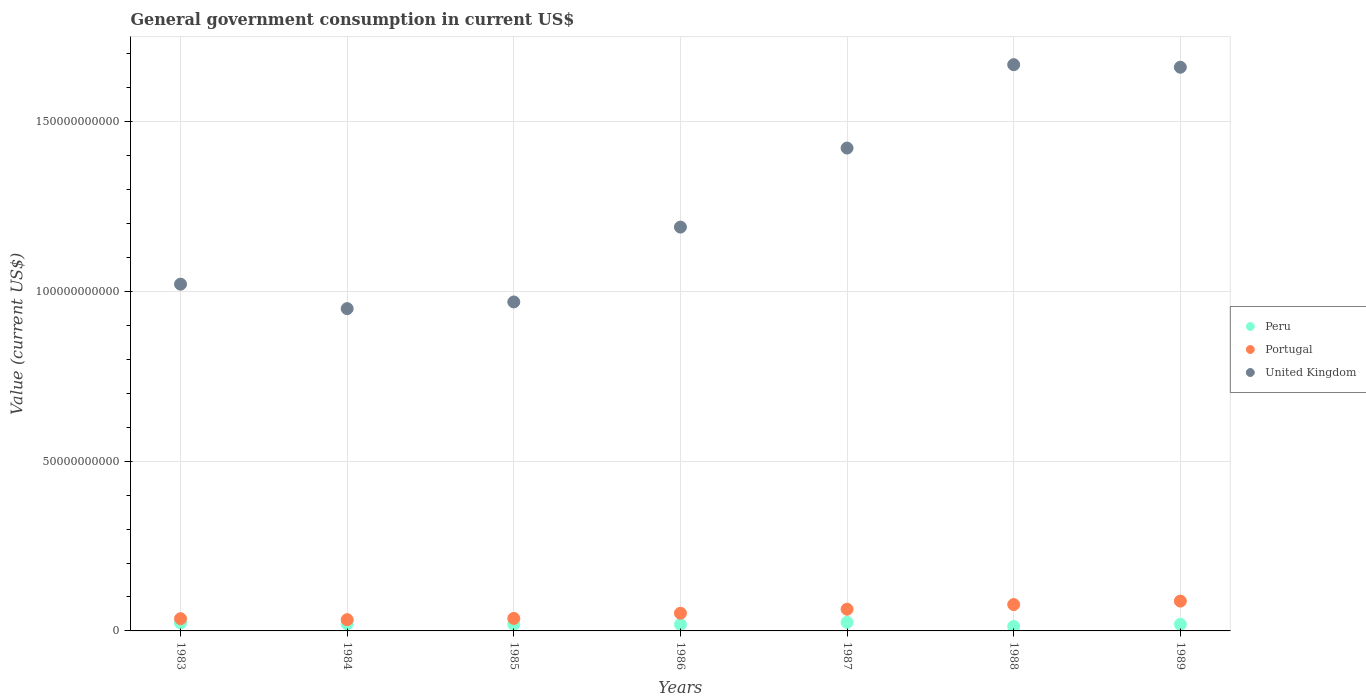How many different coloured dotlines are there?
Your response must be concise. 3. Is the number of dotlines equal to the number of legend labels?
Offer a very short reply. Yes. What is the government conusmption in Peru in 1984?
Offer a terse response. 2.08e+09. Across all years, what is the maximum government conusmption in Portugal?
Offer a terse response. 8.79e+09. Across all years, what is the minimum government conusmption in Portugal?
Offer a very short reply. 3.32e+09. In which year was the government conusmption in United Kingdom maximum?
Provide a short and direct response. 1988. In which year was the government conusmption in Portugal minimum?
Provide a succinct answer. 1984. What is the total government conusmption in Portugal in the graph?
Offer a terse response. 3.88e+1. What is the difference between the government conusmption in Peru in 1983 and that in 1987?
Keep it short and to the point. -1.93e+08. What is the difference between the government conusmption in Peru in 1985 and the government conusmption in Portugal in 1988?
Your response must be concise. -5.83e+09. What is the average government conusmption in Peru per year?
Keep it short and to the point. 2.00e+09. In the year 1986, what is the difference between the government conusmption in United Kingdom and government conusmption in Peru?
Make the answer very short. 1.17e+11. In how many years, is the government conusmption in Peru greater than 40000000000 US$?
Your answer should be compact. 0. What is the ratio of the government conusmption in United Kingdom in 1986 to that in 1987?
Keep it short and to the point. 0.84. Is the government conusmption in Peru in 1986 less than that in 1987?
Keep it short and to the point. Yes. What is the difference between the highest and the second highest government conusmption in Portugal?
Offer a very short reply. 1.02e+09. What is the difference between the highest and the lowest government conusmption in United Kingdom?
Give a very brief answer. 7.19e+1. In how many years, is the government conusmption in Portugal greater than the average government conusmption in Portugal taken over all years?
Provide a succinct answer. 3. Is the government conusmption in Peru strictly greater than the government conusmption in Portugal over the years?
Your answer should be compact. No. Is the government conusmption in Portugal strictly less than the government conusmption in United Kingdom over the years?
Provide a short and direct response. Yes. How many years are there in the graph?
Ensure brevity in your answer.  7. Does the graph contain any zero values?
Ensure brevity in your answer.  No. Where does the legend appear in the graph?
Offer a terse response. Center right. How many legend labels are there?
Offer a terse response. 3. How are the legend labels stacked?
Offer a very short reply. Vertical. What is the title of the graph?
Your answer should be very brief. General government consumption in current US$. Does "Brunei Darussalam" appear as one of the legend labels in the graph?
Offer a terse response. No. What is the label or title of the Y-axis?
Make the answer very short. Value (current US$). What is the Value (current US$) in Peru in 1983?
Your answer should be very brief. 2.33e+09. What is the Value (current US$) in Portugal in 1983?
Provide a short and direct response. 3.61e+09. What is the Value (current US$) of United Kingdom in 1983?
Your response must be concise. 1.02e+11. What is the Value (current US$) of Peru in 1984?
Provide a short and direct response. 2.08e+09. What is the Value (current US$) of Portugal in 1984?
Make the answer very short. 3.32e+09. What is the Value (current US$) of United Kingdom in 1984?
Make the answer very short. 9.49e+1. What is the Value (current US$) in Peru in 1985?
Make the answer very short. 1.94e+09. What is the Value (current US$) in Portugal in 1985?
Give a very brief answer. 3.68e+09. What is the Value (current US$) in United Kingdom in 1985?
Make the answer very short. 9.69e+1. What is the Value (current US$) in Peru in 1986?
Offer a very short reply. 1.90e+09. What is the Value (current US$) in Portugal in 1986?
Provide a succinct answer. 5.21e+09. What is the Value (current US$) of United Kingdom in 1986?
Make the answer very short. 1.19e+11. What is the Value (current US$) of Peru in 1987?
Your answer should be very brief. 2.53e+09. What is the Value (current US$) of Portugal in 1987?
Provide a succinct answer. 6.40e+09. What is the Value (current US$) in United Kingdom in 1987?
Offer a very short reply. 1.42e+11. What is the Value (current US$) in Peru in 1988?
Give a very brief answer. 1.31e+09. What is the Value (current US$) of Portugal in 1988?
Offer a very short reply. 7.77e+09. What is the Value (current US$) of United Kingdom in 1988?
Provide a short and direct response. 1.67e+11. What is the Value (current US$) of Peru in 1989?
Provide a short and direct response. 1.93e+09. What is the Value (current US$) in Portugal in 1989?
Offer a very short reply. 8.79e+09. What is the Value (current US$) in United Kingdom in 1989?
Keep it short and to the point. 1.66e+11. Across all years, what is the maximum Value (current US$) of Peru?
Your response must be concise. 2.53e+09. Across all years, what is the maximum Value (current US$) of Portugal?
Give a very brief answer. 8.79e+09. Across all years, what is the maximum Value (current US$) of United Kingdom?
Provide a short and direct response. 1.67e+11. Across all years, what is the minimum Value (current US$) in Peru?
Keep it short and to the point. 1.31e+09. Across all years, what is the minimum Value (current US$) of Portugal?
Keep it short and to the point. 3.32e+09. Across all years, what is the minimum Value (current US$) in United Kingdom?
Your response must be concise. 9.49e+1. What is the total Value (current US$) in Peru in the graph?
Provide a short and direct response. 1.40e+1. What is the total Value (current US$) in Portugal in the graph?
Give a very brief answer. 3.88e+1. What is the total Value (current US$) in United Kingdom in the graph?
Give a very brief answer. 8.88e+11. What is the difference between the Value (current US$) in Peru in 1983 and that in 1984?
Make the answer very short. 2.57e+08. What is the difference between the Value (current US$) of Portugal in 1983 and that in 1984?
Offer a terse response. 2.92e+08. What is the difference between the Value (current US$) of United Kingdom in 1983 and that in 1984?
Give a very brief answer. 7.21e+09. What is the difference between the Value (current US$) in Peru in 1983 and that in 1985?
Your answer should be very brief. 3.93e+08. What is the difference between the Value (current US$) of Portugal in 1983 and that in 1985?
Your response must be concise. -7.50e+07. What is the difference between the Value (current US$) of United Kingdom in 1983 and that in 1985?
Your response must be concise. 5.25e+09. What is the difference between the Value (current US$) in Peru in 1983 and that in 1986?
Your answer should be very brief. 4.38e+08. What is the difference between the Value (current US$) of Portugal in 1983 and that in 1986?
Offer a very short reply. -1.60e+09. What is the difference between the Value (current US$) of United Kingdom in 1983 and that in 1986?
Give a very brief answer. -1.68e+1. What is the difference between the Value (current US$) of Peru in 1983 and that in 1987?
Your answer should be compact. -1.93e+08. What is the difference between the Value (current US$) in Portugal in 1983 and that in 1987?
Give a very brief answer. -2.79e+09. What is the difference between the Value (current US$) in United Kingdom in 1983 and that in 1987?
Give a very brief answer. -4.01e+1. What is the difference between the Value (current US$) of Peru in 1983 and that in 1988?
Your answer should be very brief. 1.02e+09. What is the difference between the Value (current US$) of Portugal in 1983 and that in 1988?
Keep it short and to the point. -4.16e+09. What is the difference between the Value (current US$) of United Kingdom in 1983 and that in 1988?
Offer a very short reply. -6.46e+1. What is the difference between the Value (current US$) of Peru in 1983 and that in 1989?
Make the answer very short. 4.02e+08. What is the difference between the Value (current US$) of Portugal in 1983 and that in 1989?
Offer a terse response. -5.18e+09. What is the difference between the Value (current US$) of United Kingdom in 1983 and that in 1989?
Offer a terse response. -6.39e+1. What is the difference between the Value (current US$) in Peru in 1984 and that in 1985?
Offer a very short reply. 1.37e+08. What is the difference between the Value (current US$) in Portugal in 1984 and that in 1985?
Your answer should be very brief. -3.67e+08. What is the difference between the Value (current US$) of United Kingdom in 1984 and that in 1985?
Offer a terse response. -1.96e+09. What is the difference between the Value (current US$) in Peru in 1984 and that in 1986?
Offer a terse response. 1.82e+08. What is the difference between the Value (current US$) in Portugal in 1984 and that in 1986?
Your answer should be compact. -1.89e+09. What is the difference between the Value (current US$) in United Kingdom in 1984 and that in 1986?
Provide a succinct answer. -2.40e+1. What is the difference between the Value (current US$) in Peru in 1984 and that in 1987?
Your answer should be compact. -4.50e+08. What is the difference between the Value (current US$) in Portugal in 1984 and that in 1987?
Your answer should be very brief. -3.08e+09. What is the difference between the Value (current US$) of United Kingdom in 1984 and that in 1987?
Offer a very short reply. -4.73e+1. What is the difference between the Value (current US$) in Peru in 1984 and that in 1988?
Keep it short and to the point. 7.63e+08. What is the difference between the Value (current US$) in Portugal in 1984 and that in 1988?
Ensure brevity in your answer.  -4.45e+09. What is the difference between the Value (current US$) in United Kingdom in 1984 and that in 1988?
Offer a terse response. -7.19e+1. What is the difference between the Value (current US$) in Peru in 1984 and that in 1989?
Offer a very short reply. 1.45e+08. What is the difference between the Value (current US$) of Portugal in 1984 and that in 1989?
Your answer should be compact. -5.47e+09. What is the difference between the Value (current US$) in United Kingdom in 1984 and that in 1989?
Give a very brief answer. -7.11e+1. What is the difference between the Value (current US$) of Peru in 1985 and that in 1986?
Your answer should be very brief. 4.50e+07. What is the difference between the Value (current US$) in Portugal in 1985 and that in 1986?
Make the answer very short. -1.52e+09. What is the difference between the Value (current US$) of United Kingdom in 1985 and that in 1986?
Your answer should be very brief. -2.21e+1. What is the difference between the Value (current US$) in Peru in 1985 and that in 1987?
Your response must be concise. -5.87e+08. What is the difference between the Value (current US$) in Portugal in 1985 and that in 1987?
Your response must be concise. -2.71e+09. What is the difference between the Value (current US$) in United Kingdom in 1985 and that in 1987?
Make the answer very short. -4.53e+1. What is the difference between the Value (current US$) in Peru in 1985 and that in 1988?
Your response must be concise. 6.26e+08. What is the difference between the Value (current US$) of Portugal in 1985 and that in 1988?
Ensure brevity in your answer.  -4.08e+09. What is the difference between the Value (current US$) in United Kingdom in 1985 and that in 1988?
Your answer should be compact. -6.99e+1. What is the difference between the Value (current US$) in Peru in 1985 and that in 1989?
Provide a succinct answer. 8.56e+06. What is the difference between the Value (current US$) of Portugal in 1985 and that in 1989?
Offer a very short reply. -5.10e+09. What is the difference between the Value (current US$) of United Kingdom in 1985 and that in 1989?
Provide a short and direct response. -6.91e+1. What is the difference between the Value (current US$) of Peru in 1986 and that in 1987?
Provide a succinct answer. -6.32e+08. What is the difference between the Value (current US$) in Portugal in 1986 and that in 1987?
Give a very brief answer. -1.19e+09. What is the difference between the Value (current US$) of United Kingdom in 1986 and that in 1987?
Ensure brevity in your answer.  -2.33e+1. What is the difference between the Value (current US$) in Peru in 1986 and that in 1988?
Your response must be concise. 5.81e+08. What is the difference between the Value (current US$) of Portugal in 1986 and that in 1988?
Offer a very short reply. -2.56e+09. What is the difference between the Value (current US$) of United Kingdom in 1986 and that in 1988?
Keep it short and to the point. -4.78e+1. What is the difference between the Value (current US$) in Peru in 1986 and that in 1989?
Your response must be concise. -3.64e+07. What is the difference between the Value (current US$) of Portugal in 1986 and that in 1989?
Offer a terse response. -3.58e+09. What is the difference between the Value (current US$) in United Kingdom in 1986 and that in 1989?
Your answer should be compact. -4.71e+1. What is the difference between the Value (current US$) in Peru in 1987 and that in 1988?
Ensure brevity in your answer.  1.21e+09. What is the difference between the Value (current US$) of Portugal in 1987 and that in 1988?
Provide a short and direct response. -1.37e+09. What is the difference between the Value (current US$) of United Kingdom in 1987 and that in 1988?
Your answer should be compact. -2.46e+1. What is the difference between the Value (current US$) in Peru in 1987 and that in 1989?
Make the answer very short. 5.95e+08. What is the difference between the Value (current US$) of Portugal in 1987 and that in 1989?
Keep it short and to the point. -2.39e+09. What is the difference between the Value (current US$) of United Kingdom in 1987 and that in 1989?
Ensure brevity in your answer.  -2.38e+1. What is the difference between the Value (current US$) of Peru in 1988 and that in 1989?
Your response must be concise. -6.18e+08. What is the difference between the Value (current US$) in Portugal in 1988 and that in 1989?
Ensure brevity in your answer.  -1.02e+09. What is the difference between the Value (current US$) in United Kingdom in 1988 and that in 1989?
Offer a very short reply. 7.54e+08. What is the difference between the Value (current US$) in Peru in 1983 and the Value (current US$) in Portugal in 1984?
Provide a short and direct response. -9.84e+08. What is the difference between the Value (current US$) of Peru in 1983 and the Value (current US$) of United Kingdom in 1984?
Offer a terse response. -9.26e+1. What is the difference between the Value (current US$) of Portugal in 1983 and the Value (current US$) of United Kingdom in 1984?
Keep it short and to the point. -9.13e+1. What is the difference between the Value (current US$) in Peru in 1983 and the Value (current US$) in Portugal in 1985?
Give a very brief answer. -1.35e+09. What is the difference between the Value (current US$) of Peru in 1983 and the Value (current US$) of United Kingdom in 1985?
Make the answer very short. -9.46e+1. What is the difference between the Value (current US$) in Portugal in 1983 and the Value (current US$) in United Kingdom in 1985?
Ensure brevity in your answer.  -9.33e+1. What is the difference between the Value (current US$) in Peru in 1983 and the Value (current US$) in Portugal in 1986?
Provide a succinct answer. -2.88e+09. What is the difference between the Value (current US$) of Peru in 1983 and the Value (current US$) of United Kingdom in 1986?
Give a very brief answer. -1.17e+11. What is the difference between the Value (current US$) in Portugal in 1983 and the Value (current US$) in United Kingdom in 1986?
Give a very brief answer. -1.15e+11. What is the difference between the Value (current US$) in Peru in 1983 and the Value (current US$) in Portugal in 1987?
Provide a short and direct response. -4.06e+09. What is the difference between the Value (current US$) of Peru in 1983 and the Value (current US$) of United Kingdom in 1987?
Make the answer very short. -1.40e+11. What is the difference between the Value (current US$) of Portugal in 1983 and the Value (current US$) of United Kingdom in 1987?
Provide a short and direct response. -1.39e+11. What is the difference between the Value (current US$) in Peru in 1983 and the Value (current US$) in Portugal in 1988?
Make the answer very short. -5.43e+09. What is the difference between the Value (current US$) of Peru in 1983 and the Value (current US$) of United Kingdom in 1988?
Your answer should be very brief. -1.64e+11. What is the difference between the Value (current US$) in Portugal in 1983 and the Value (current US$) in United Kingdom in 1988?
Give a very brief answer. -1.63e+11. What is the difference between the Value (current US$) of Peru in 1983 and the Value (current US$) of Portugal in 1989?
Give a very brief answer. -6.45e+09. What is the difference between the Value (current US$) of Peru in 1983 and the Value (current US$) of United Kingdom in 1989?
Ensure brevity in your answer.  -1.64e+11. What is the difference between the Value (current US$) of Portugal in 1983 and the Value (current US$) of United Kingdom in 1989?
Offer a terse response. -1.62e+11. What is the difference between the Value (current US$) in Peru in 1984 and the Value (current US$) in Portugal in 1985?
Ensure brevity in your answer.  -1.61e+09. What is the difference between the Value (current US$) in Peru in 1984 and the Value (current US$) in United Kingdom in 1985?
Give a very brief answer. -9.48e+1. What is the difference between the Value (current US$) in Portugal in 1984 and the Value (current US$) in United Kingdom in 1985?
Your response must be concise. -9.36e+1. What is the difference between the Value (current US$) in Peru in 1984 and the Value (current US$) in Portugal in 1986?
Ensure brevity in your answer.  -3.13e+09. What is the difference between the Value (current US$) in Peru in 1984 and the Value (current US$) in United Kingdom in 1986?
Your answer should be compact. -1.17e+11. What is the difference between the Value (current US$) in Portugal in 1984 and the Value (current US$) in United Kingdom in 1986?
Provide a succinct answer. -1.16e+11. What is the difference between the Value (current US$) in Peru in 1984 and the Value (current US$) in Portugal in 1987?
Keep it short and to the point. -4.32e+09. What is the difference between the Value (current US$) of Peru in 1984 and the Value (current US$) of United Kingdom in 1987?
Give a very brief answer. -1.40e+11. What is the difference between the Value (current US$) in Portugal in 1984 and the Value (current US$) in United Kingdom in 1987?
Make the answer very short. -1.39e+11. What is the difference between the Value (current US$) of Peru in 1984 and the Value (current US$) of Portugal in 1988?
Ensure brevity in your answer.  -5.69e+09. What is the difference between the Value (current US$) in Peru in 1984 and the Value (current US$) in United Kingdom in 1988?
Provide a short and direct response. -1.65e+11. What is the difference between the Value (current US$) in Portugal in 1984 and the Value (current US$) in United Kingdom in 1988?
Offer a very short reply. -1.63e+11. What is the difference between the Value (current US$) in Peru in 1984 and the Value (current US$) in Portugal in 1989?
Your answer should be very brief. -6.71e+09. What is the difference between the Value (current US$) in Peru in 1984 and the Value (current US$) in United Kingdom in 1989?
Provide a short and direct response. -1.64e+11. What is the difference between the Value (current US$) of Portugal in 1984 and the Value (current US$) of United Kingdom in 1989?
Give a very brief answer. -1.63e+11. What is the difference between the Value (current US$) of Peru in 1985 and the Value (current US$) of Portugal in 1986?
Your answer should be very brief. -3.27e+09. What is the difference between the Value (current US$) in Peru in 1985 and the Value (current US$) in United Kingdom in 1986?
Ensure brevity in your answer.  -1.17e+11. What is the difference between the Value (current US$) in Portugal in 1985 and the Value (current US$) in United Kingdom in 1986?
Offer a terse response. -1.15e+11. What is the difference between the Value (current US$) of Peru in 1985 and the Value (current US$) of Portugal in 1987?
Give a very brief answer. -4.46e+09. What is the difference between the Value (current US$) in Peru in 1985 and the Value (current US$) in United Kingdom in 1987?
Provide a short and direct response. -1.40e+11. What is the difference between the Value (current US$) of Portugal in 1985 and the Value (current US$) of United Kingdom in 1987?
Make the answer very short. -1.39e+11. What is the difference between the Value (current US$) in Peru in 1985 and the Value (current US$) in Portugal in 1988?
Your answer should be compact. -5.83e+09. What is the difference between the Value (current US$) in Peru in 1985 and the Value (current US$) in United Kingdom in 1988?
Your answer should be compact. -1.65e+11. What is the difference between the Value (current US$) of Portugal in 1985 and the Value (current US$) of United Kingdom in 1988?
Provide a short and direct response. -1.63e+11. What is the difference between the Value (current US$) in Peru in 1985 and the Value (current US$) in Portugal in 1989?
Offer a very short reply. -6.85e+09. What is the difference between the Value (current US$) in Peru in 1985 and the Value (current US$) in United Kingdom in 1989?
Offer a very short reply. -1.64e+11. What is the difference between the Value (current US$) of Portugal in 1985 and the Value (current US$) of United Kingdom in 1989?
Your answer should be compact. -1.62e+11. What is the difference between the Value (current US$) of Peru in 1986 and the Value (current US$) of Portugal in 1987?
Make the answer very short. -4.50e+09. What is the difference between the Value (current US$) in Peru in 1986 and the Value (current US$) in United Kingdom in 1987?
Your answer should be compact. -1.40e+11. What is the difference between the Value (current US$) in Portugal in 1986 and the Value (current US$) in United Kingdom in 1987?
Provide a short and direct response. -1.37e+11. What is the difference between the Value (current US$) in Peru in 1986 and the Value (current US$) in Portugal in 1988?
Provide a succinct answer. -5.87e+09. What is the difference between the Value (current US$) of Peru in 1986 and the Value (current US$) of United Kingdom in 1988?
Your answer should be compact. -1.65e+11. What is the difference between the Value (current US$) of Portugal in 1986 and the Value (current US$) of United Kingdom in 1988?
Provide a short and direct response. -1.62e+11. What is the difference between the Value (current US$) of Peru in 1986 and the Value (current US$) of Portugal in 1989?
Your answer should be very brief. -6.89e+09. What is the difference between the Value (current US$) in Peru in 1986 and the Value (current US$) in United Kingdom in 1989?
Give a very brief answer. -1.64e+11. What is the difference between the Value (current US$) of Portugal in 1986 and the Value (current US$) of United Kingdom in 1989?
Keep it short and to the point. -1.61e+11. What is the difference between the Value (current US$) of Peru in 1987 and the Value (current US$) of Portugal in 1988?
Your response must be concise. -5.24e+09. What is the difference between the Value (current US$) in Peru in 1987 and the Value (current US$) in United Kingdom in 1988?
Your answer should be very brief. -1.64e+11. What is the difference between the Value (current US$) in Portugal in 1987 and the Value (current US$) in United Kingdom in 1988?
Provide a short and direct response. -1.60e+11. What is the difference between the Value (current US$) in Peru in 1987 and the Value (current US$) in Portugal in 1989?
Your answer should be compact. -6.26e+09. What is the difference between the Value (current US$) of Peru in 1987 and the Value (current US$) of United Kingdom in 1989?
Make the answer very short. -1.64e+11. What is the difference between the Value (current US$) in Portugal in 1987 and the Value (current US$) in United Kingdom in 1989?
Give a very brief answer. -1.60e+11. What is the difference between the Value (current US$) of Peru in 1988 and the Value (current US$) of Portugal in 1989?
Ensure brevity in your answer.  -7.47e+09. What is the difference between the Value (current US$) in Peru in 1988 and the Value (current US$) in United Kingdom in 1989?
Offer a very short reply. -1.65e+11. What is the difference between the Value (current US$) in Portugal in 1988 and the Value (current US$) in United Kingdom in 1989?
Offer a terse response. -1.58e+11. What is the average Value (current US$) of Peru per year?
Your response must be concise. 2.00e+09. What is the average Value (current US$) of Portugal per year?
Offer a terse response. 5.54e+09. What is the average Value (current US$) of United Kingdom per year?
Your response must be concise. 1.27e+11. In the year 1983, what is the difference between the Value (current US$) in Peru and Value (current US$) in Portugal?
Your response must be concise. -1.28e+09. In the year 1983, what is the difference between the Value (current US$) of Peru and Value (current US$) of United Kingdom?
Ensure brevity in your answer.  -9.98e+1. In the year 1983, what is the difference between the Value (current US$) of Portugal and Value (current US$) of United Kingdom?
Offer a very short reply. -9.85e+1. In the year 1984, what is the difference between the Value (current US$) in Peru and Value (current US$) in Portugal?
Your response must be concise. -1.24e+09. In the year 1984, what is the difference between the Value (current US$) of Peru and Value (current US$) of United Kingdom?
Keep it short and to the point. -9.29e+1. In the year 1984, what is the difference between the Value (current US$) in Portugal and Value (current US$) in United Kingdom?
Provide a succinct answer. -9.16e+1. In the year 1985, what is the difference between the Value (current US$) of Peru and Value (current US$) of Portugal?
Provide a short and direct response. -1.74e+09. In the year 1985, what is the difference between the Value (current US$) in Peru and Value (current US$) in United Kingdom?
Your answer should be compact. -9.50e+1. In the year 1985, what is the difference between the Value (current US$) in Portugal and Value (current US$) in United Kingdom?
Your response must be concise. -9.32e+1. In the year 1986, what is the difference between the Value (current US$) in Peru and Value (current US$) in Portugal?
Ensure brevity in your answer.  -3.31e+09. In the year 1986, what is the difference between the Value (current US$) in Peru and Value (current US$) in United Kingdom?
Ensure brevity in your answer.  -1.17e+11. In the year 1986, what is the difference between the Value (current US$) of Portugal and Value (current US$) of United Kingdom?
Provide a succinct answer. -1.14e+11. In the year 1987, what is the difference between the Value (current US$) of Peru and Value (current US$) of Portugal?
Your response must be concise. -3.87e+09. In the year 1987, what is the difference between the Value (current US$) in Peru and Value (current US$) in United Kingdom?
Keep it short and to the point. -1.40e+11. In the year 1987, what is the difference between the Value (current US$) of Portugal and Value (current US$) of United Kingdom?
Offer a very short reply. -1.36e+11. In the year 1988, what is the difference between the Value (current US$) in Peru and Value (current US$) in Portugal?
Make the answer very short. -6.45e+09. In the year 1988, what is the difference between the Value (current US$) in Peru and Value (current US$) in United Kingdom?
Provide a short and direct response. -1.65e+11. In the year 1988, what is the difference between the Value (current US$) in Portugal and Value (current US$) in United Kingdom?
Give a very brief answer. -1.59e+11. In the year 1989, what is the difference between the Value (current US$) in Peru and Value (current US$) in Portugal?
Give a very brief answer. -6.85e+09. In the year 1989, what is the difference between the Value (current US$) of Peru and Value (current US$) of United Kingdom?
Ensure brevity in your answer.  -1.64e+11. In the year 1989, what is the difference between the Value (current US$) of Portugal and Value (current US$) of United Kingdom?
Keep it short and to the point. -1.57e+11. What is the ratio of the Value (current US$) of Peru in 1983 to that in 1984?
Make the answer very short. 1.12. What is the ratio of the Value (current US$) of Portugal in 1983 to that in 1984?
Your answer should be very brief. 1.09. What is the ratio of the Value (current US$) in United Kingdom in 1983 to that in 1984?
Keep it short and to the point. 1.08. What is the ratio of the Value (current US$) of Peru in 1983 to that in 1985?
Ensure brevity in your answer.  1.2. What is the ratio of the Value (current US$) of Portugal in 1983 to that in 1985?
Give a very brief answer. 0.98. What is the ratio of the Value (current US$) of United Kingdom in 1983 to that in 1985?
Provide a short and direct response. 1.05. What is the ratio of the Value (current US$) of Peru in 1983 to that in 1986?
Ensure brevity in your answer.  1.23. What is the ratio of the Value (current US$) of Portugal in 1983 to that in 1986?
Your response must be concise. 0.69. What is the ratio of the Value (current US$) of United Kingdom in 1983 to that in 1986?
Offer a terse response. 0.86. What is the ratio of the Value (current US$) of Peru in 1983 to that in 1987?
Your response must be concise. 0.92. What is the ratio of the Value (current US$) of Portugal in 1983 to that in 1987?
Ensure brevity in your answer.  0.56. What is the ratio of the Value (current US$) of United Kingdom in 1983 to that in 1987?
Ensure brevity in your answer.  0.72. What is the ratio of the Value (current US$) of Peru in 1983 to that in 1988?
Give a very brief answer. 1.78. What is the ratio of the Value (current US$) in Portugal in 1983 to that in 1988?
Your response must be concise. 0.46. What is the ratio of the Value (current US$) of United Kingdom in 1983 to that in 1988?
Provide a succinct answer. 0.61. What is the ratio of the Value (current US$) of Peru in 1983 to that in 1989?
Your response must be concise. 1.21. What is the ratio of the Value (current US$) in Portugal in 1983 to that in 1989?
Provide a succinct answer. 0.41. What is the ratio of the Value (current US$) of United Kingdom in 1983 to that in 1989?
Offer a terse response. 0.62. What is the ratio of the Value (current US$) of Peru in 1984 to that in 1985?
Your response must be concise. 1.07. What is the ratio of the Value (current US$) of Portugal in 1984 to that in 1985?
Make the answer very short. 0.9. What is the ratio of the Value (current US$) in United Kingdom in 1984 to that in 1985?
Provide a succinct answer. 0.98. What is the ratio of the Value (current US$) in Peru in 1984 to that in 1986?
Your answer should be very brief. 1.1. What is the ratio of the Value (current US$) of Portugal in 1984 to that in 1986?
Your response must be concise. 0.64. What is the ratio of the Value (current US$) of United Kingdom in 1984 to that in 1986?
Your response must be concise. 0.8. What is the ratio of the Value (current US$) of Peru in 1984 to that in 1987?
Make the answer very short. 0.82. What is the ratio of the Value (current US$) in Portugal in 1984 to that in 1987?
Offer a very short reply. 0.52. What is the ratio of the Value (current US$) in United Kingdom in 1984 to that in 1987?
Your answer should be compact. 0.67. What is the ratio of the Value (current US$) in Peru in 1984 to that in 1988?
Give a very brief answer. 1.58. What is the ratio of the Value (current US$) in Portugal in 1984 to that in 1988?
Your answer should be compact. 0.43. What is the ratio of the Value (current US$) of United Kingdom in 1984 to that in 1988?
Give a very brief answer. 0.57. What is the ratio of the Value (current US$) of Peru in 1984 to that in 1989?
Keep it short and to the point. 1.08. What is the ratio of the Value (current US$) of Portugal in 1984 to that in 1989?
Your response must be concise. 0.38. What is the ratio of the Value (current US$) in United Kingdom in 1984 to that in 1989?
Offer a very short reply. 0.57. What is the ratio of the Value (current US$) in Peru in 1985 to that in 1986?
Keep it short and to the point. 1.02. What is the ratio of the Value (current US$) of Portugal in 1985 to that in 1986?
Your answer should be compact. 0.71. What is the ratio of the Value (current US$) of United Kingdom in 1985 to that in 1986?
Give a very brief answer. 0.81. What is the ratio of the Value (current US$) in Peru in 1985 to that in 1987?
Your response must be concise. 0.77. What is the ratio of the Value (current US$) in Portugal in 1985 to that in 1987?
Your answer should be compact. 0.58. What is the ratio of the Value (current US$) of United Kingdom in 1985 to that in 1987?
Provide a succinct answer. 0.68. What is the ratio of the Value (current US$) in Peru in 1985 to that in 1988?
Keep it short and to the point. 1.48. What is the ratio of the Value (current US$) of Portugal in 1985 to that in 1988?
Your answer should be very brief. 0.47. What is the ratio of the Value (current US$) in United Kingdom in 1985 to that in 1988?
Keep it short and to the point. 0.58. What is the ratio of the Value (current US$) in Peru in 1985 to that in 1989?
Your response must be concise. 1. What is the ratio of the Value (current US$) of Portugal in 1985 to that in 1989?
Provide a succinct answer. 0.42. What is the ratio of the Value (current US$) in United Kingdom in 1985 to that in 1989?
Your answer should be very brief. 0.58. What is the ratio of the Value (current US$) in Peru in 1986 to that in 1987?
Your answer should be very brief. 0.75. What is the ratio of the Value (current US$) of Portugal in 1986 to that in 1987?
Provide a succinct answer. 0.81. What is the ratio of the Value (current US$) in United Kingdom in 1986 to that in 1987?
Provide a succinct answer. 0.84. What is the ratio of the Value (current US$) in Peru in 1986 to that in 1988?
Provide a short and direct response. 1.44. What is the ratio of the Value (current US$) of Portugal in 1986 to that in 1988?
Your answer should be very brief. 0.67. What is the ratio of the Value (current US$) in United Kingdom in 1986 to that in 1988?
Offer a terse response. 0.71. What is the ratio of the Value (current US$) of Peru in 1986 to that in 1989?
Your answer should be compact. 0.98. What is the ratio of the Value (current US$) of Portugal in 1986 to that in 1989?
Your response must be concise. 0.59. What is the ratio of the Value (current US$) in United Kingdom in 1986 to that in 1989?
Provide a succinct answer. 0.72. What is the ratio of the Value (current US$) of Peru in 1987 to that in 1988?
Your answer should be compact. 1.92. What is the ratio of the Value (current US$) in Portugal in 1987 to that in 1988?
Your answer should be compact. 0.82. What is the ratio of the Value (current US$) of United Kingdom in 1987 to that in 1988?
Make the answer very short. 0.85. What is the ratio of the Value (current US$) of Peru in 1987 to that in 1989?
Your answer should be very brief. 1.31. What is the ratio of the Value (current US$) of Portugal in 1987 to that in 1989?
Your response must be concise. 0.73. What is the ratio of the Value (current US$) of United Kingdom in 1987 to that in 1989?
Offer a terse response. 0.86. What is the ratio of the Value (current US$) of Peru in 1988 to that in 1989?
Provide a short and direct response. 0.68. What is the ratio of the Value (current US$) in Portugal in 1988 to that in 1989?
Provide a short and direct response. 0.88. What is the ratio of the Value (current US$) of United Kingdom in 1988 to that in 1989?
Give a very brief answer. 1. What is the difference between the highest and the second highest Value (current US$) of Peru?
Provide a short and direct response. 1.93e+08. What is the difference between the highest and the second highest Value (current US$) of Portugal?
Make the answer very short. 1.02e+09. What is the difference between the highest and the second highest Value (current US$) in United Kingdom?
Make the answer very short. 7.54e+08. What is the difference between the highest and the lowest Value (current US$) in Peru?
Your answer should be very brief. 1.21e+09. What is the difference between the highest and the lowest Value (current US$) of Portugal?
Offer a very short reply. 5.47e+09. What is the difference between the highest and the lowest Value (current US$) of United Kingdom?
Your response must be concise. 7.19e+1. 